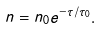<formula> <loc_0><loc_0><loc_500><loc_500>n = n _ { 0 } e ^ { - \tau / \tau _ { 0 } } .</formula> 